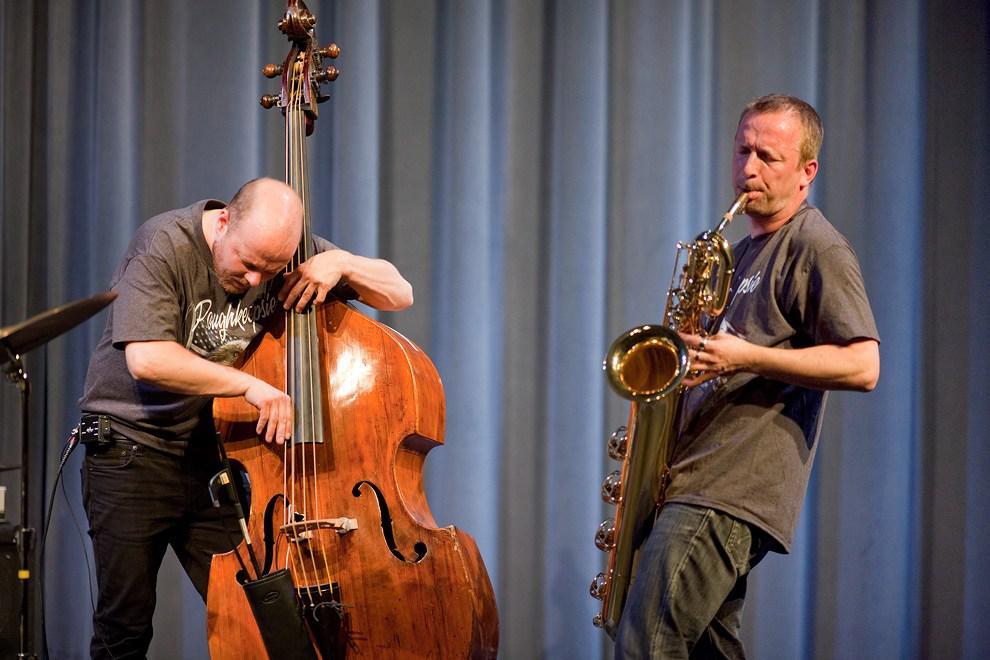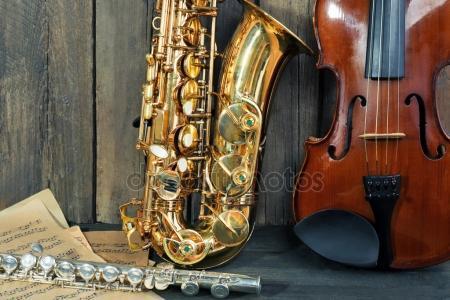The first image is the image on the left, the second image is the image on the right. Given the left and right images, does the statement "Only a single saxophone in each picture." hold true? Answer yes or no. Yes. The first image is the image on the left, the second image is the image on the right. Examine the images to the left and right. Is the description "The right image contains a violin, sax and flute." accurate? Answer yes or no. Yes. 